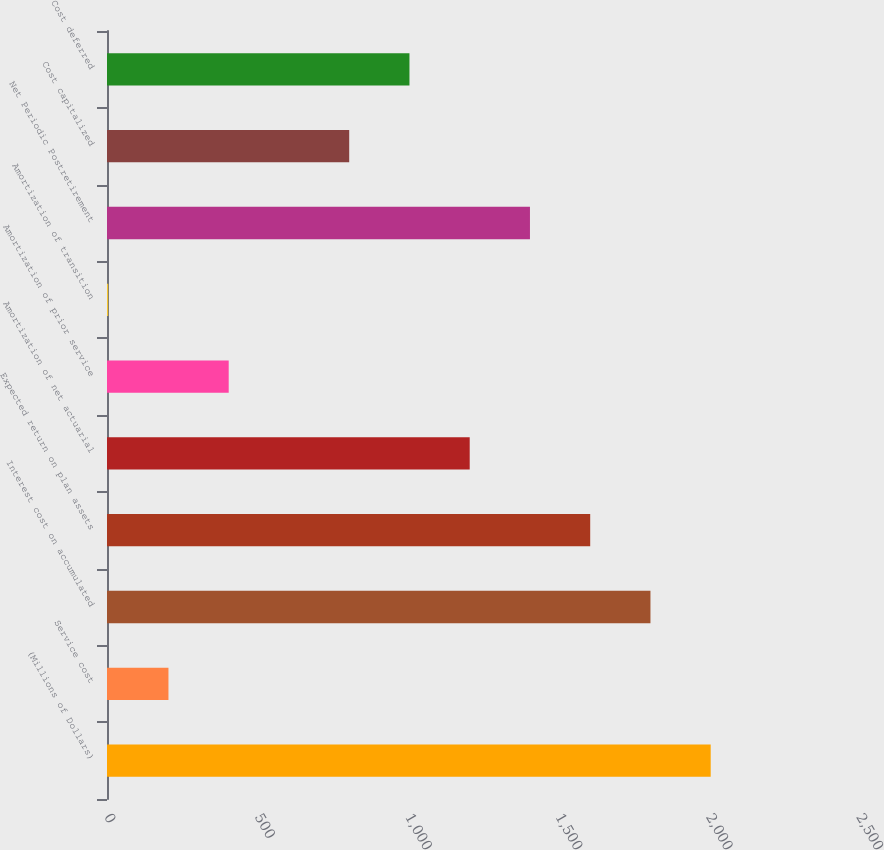<chart> <loc_0><loc_0><loc_500><loc_500><bar_chart><fcel>(Millions of Dollars)<fcel>Service cost<fcel>Interest cost on accumulated<fcel>Expected return on plan assets<fcel>Amortization of net actuarial<fcel>Amortization of prior service<fcel>Amortization of transition<fcel>Net Periodic Postretirement<fcel>Cost capitalized<fcel>Cost deferred<nl><fcel>2007<fcel>204.3<fcel>1806.7<fcel>1606.4<fcel>1205.8<fcel>404.6<fcel>4<fcel>1406.1<fcel>805.2<fcel>1005.5<nl></chart> 